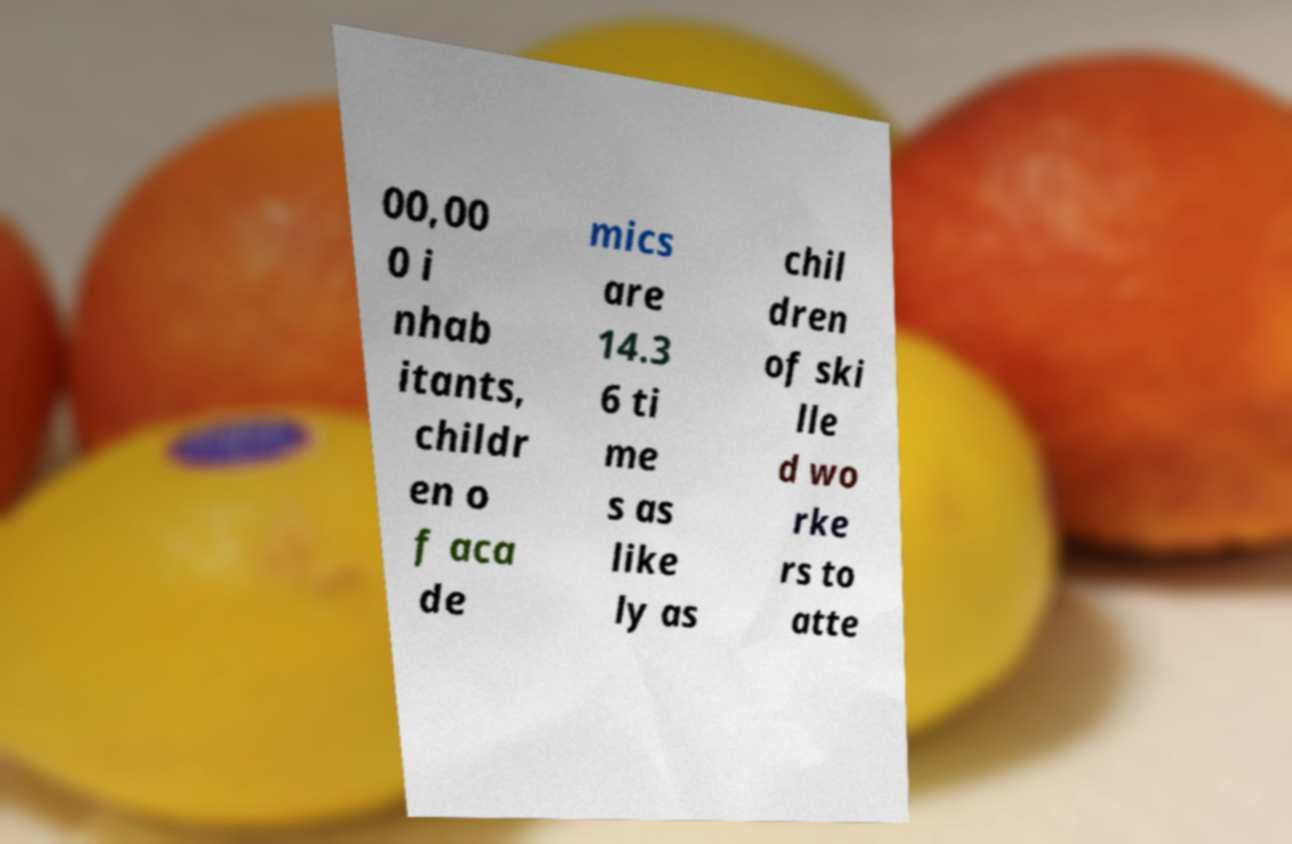I need the written content from this picture converted into text. Can you do that? 00,00 0 i nhab itants, childr en o f aca de mics are 14.3 6 ti me s as like ly as chil dren of ski lle d wo rke rs to atte 